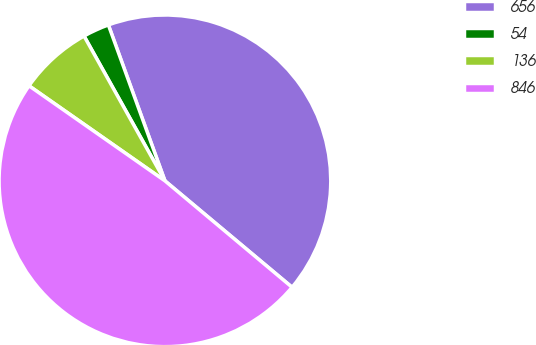Convert chart to OTSL. <chart><loc_0><loc_0><loc_500><loc_500><pie_chart><fcel>656<fcel>54<fcel>136<fcel>846<nl><fcel>41.63%<fcel>2.57%<fcel>7.18%<fcel>48.62%<nl></chart> 